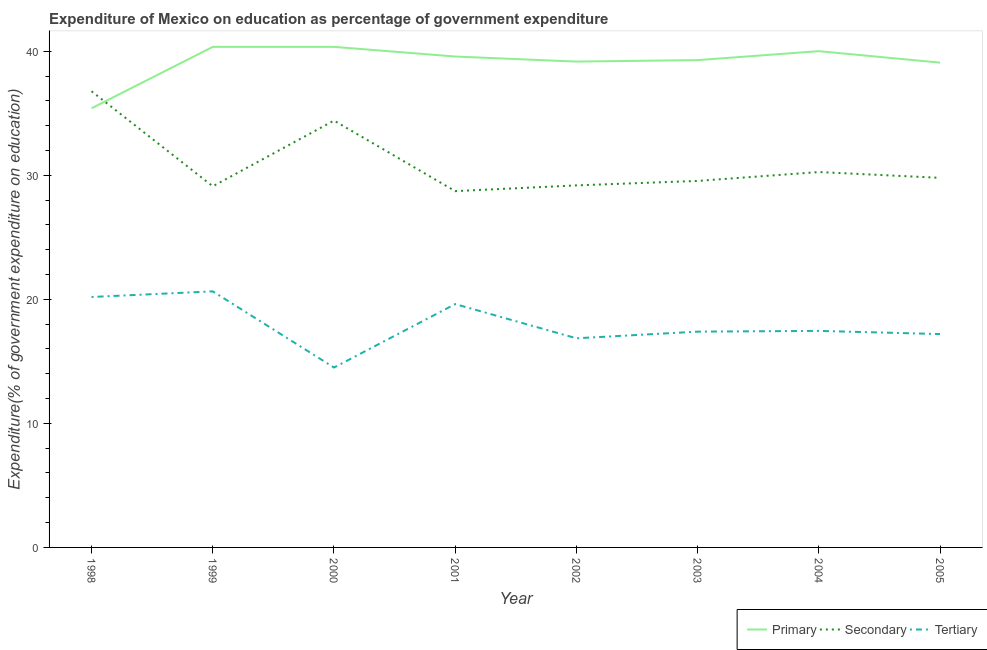Does the line corresponding to expenditure on tertiary education intersect with the line corresponding to expenditure on primary education?
Your answer should be very brief. No. What is the expenditure on secondary education in 2003?
Give a very brief answer. 29.54. Across all years, what is the maximum expenditure on primary education?
Keep it short and to the point. 40.35. Across all years, what is the minimum expenditure on primary education?
Your answer should be compact. 35.4. In which year was the expenditure on tertiary education minimum?
Give a very brief answer. 2000. What is the total expenditure on secondary education in the graph?
Keep it short and to the point. 247.79. What is the difference between the expenditure on tertiary education in 1998 and that in 2000?
Ensure brevity in your answer.  5.69. What is the difference between the expenditure on tertiary education in 2004 and the expenditure on primary education in 2000?
Give a very brief answer. -22.9. What is the average expenditure on tertiary education per year?
Your answer should be compact. 17.98. In the year 1998, what is the difference between the expenditure on tertiary education and expenditure on secondary education?
Make the answer very short. -16.58. What is the ratio of the expenditure on secondary education in 1999 to that in 2002?
Make the answer very short. 1. What is the difference between the highest and the second highest expenditure on secondary education?
Your response must be concise. 2.37. What is the difference between the highest and the lowest expenditure on primary education?
Make the answer very short. 4.95. In how many years, is the expenditure on secondary education greater than the average expenditure on secondary education taken over all years?
Offer a terse response. 2. Is the sum of the expenditure on tertiary education in 1999 and 2005 greater than the maximum expenditure on secondary education across all years?
Provide a short and direct response. Yes. Is it the case that in every year, the sum of the expenditure on primary education and expenditure on secondary education is greater than the expenditure on tertiary education?
Give a very brief answer. Yes. Is the expenditure on secondary education strictly greater than the expenditure on primary education over the years?
Offer a terse response. No. What is the difference between two consecutive major ticks on the Y-axis?
Give a very brief answer. 10. Does the graph contain any zero values?
Your answer should be very brief. No. Does the graph contain grids?
Keep it short and to the point. No. How many legend labels are there?
Your answer should be very brief. 3. What is the title of the graph?
Give a very brief answer. Expenditure of Mexico on education as percentage of government expenditure. Does "Agriculture" appear as one of the legend labels in the graph?
Give a very brief answer. No. What is the label or title of the Y-axis?
Offer a terse response. Expenditure(% of government expenditure on education). What is the Expenditure(% of government expenditure on education) of Primary in 1998?
Your answer should be compact. 35.4. What is the Expenditure(% of government expenditure on education) in Secondary in 1998?
Your answer should be very brief. 36.77. What is the Expenditure(% of government expenditure on education) in Tertiary in 1998?
Offer a very short reply. 20.19. What is the Expenditure(% of government expenditure on education) in Primary in 1999?
Offer a very short reply. 40.35. What is the Expenditure(% of government expenditure on education) of Secondary in 1999?
Keep it short and to the point. 29.11. What is the Expenditure(% of government expenditure on education) in Tertiary in 1999?
Offer a terse response. 20.64. What is the Expenditure(% of government expenditure on education) in Primary in 2000?
Your answer should be compact. 40.35. What is the Expenditure(% of government expenditure on education) of Secondary in 2000?
Provide a short and direct response. 34.41. What is the Expenditure(% of government expenditure on education) in Tertiary in 2000?
Your answer should be compact. 14.5. What is the Expenditure(% of government expenditure on education) of Primary in 2001?
Make the answer very short. 39.57. What is the Expenditure(% of government expenditure on education) of Secondary in 2001?
Provide a short and direct response. 28.72. What is the Expenditure(% of government expenditure on education) in Tertiary in 2001?
Provide a succinct answer. 19.62. What is the Expenditure(% of government expenditure on education) of Primary in 2002?
Give a very brief answer. 39.16. What is the Expenditure(% of government expenditure on education) in Secondary in 2002?
Keep it short and to the point. 29.18. What is the Expenditure(% of government expenditure on education) in Tertiary in 2002?
Give a very brief answer. 16.86. What is the Expenditure(% of government expenditure on education) in Primary in 2003?
Make the answer very short. 39.28. What is the Expenditure(% of government expenditure on education) of Secondary in 2003?
Ensure brevity in your answer.  29.54. What is the Expenditure(% of government expenditure on education) in Tertiary in 2003?
Your answer should be very brief. 17.39. What is the Expenditure(% of government expenditure on education) in Primary in 2004?
Make the answer very short. 40. What is the Expenditure(% of government expenditure on education) of Secondary in 2004?
Your response must be concise. 30.26. What is the Expenditure(% of government expenditure on education) of Tertiary in 2004?
Provide a succinct answer. 17.45. What is the Expenditure(% of government expenditure on education) of Primary in 2005?
Your answer should be compact. 39.08. What is the Expenditure(% of government expenditure on education) of Secondary in 2005?
Your answer should be very brief. 29.79. What is the Expenditure(% of government expenditure on education) in Tertiary in 2005?
Provide a succinct answer. 17.2. Across all years, what is the maximum Expenditure(% of government expenditure on education) of Primary?
Your response must be concise. 40.35. Across all years, what is the maximum Expenditure(% of government expenditure on education) in Secondary?
Provide a short and direct response. 36.77. Across all years, what is the maximum Expenditure(% of government expenditure on education) in Tertiary?
Offer a terse response. 20.64. Across all years, what is the minimum Expenditure(% of government expenditure on education) in Primary?
Keep it short and to the point. 35.4. Across all years, what is the minimum Expenditure(% of government expenditure on education) in Secondary?
Offer a terse response. 28.72. Across all years, what is the minimum Expenditure(% of government expenditure on education) in Tertiary?
Give a very brief answer. 14.5. What is the total Expenditure(% of government expenditure on education) of Primary in the graph?
Provide a succinct answer. 313.2. What is the total Expenditure(% of government expenditure on education) of Secondary in the graph?
Make the answer very short. 247.79. What is the total Expenditure(% of government expenditure on education) of Tertiary in the graph?
Provide a succinct answer. 143.85. What is the difference between the Expenditure(% of government expenditure on education) in Primary in 1998 and that in 1999?
Keep it short and to the point. -4.95. What is the difference between the Expenditure(% of government expenditure on education) of Secondary in 1998 and that in 1999?
Give a very brief answer. 7.66. What is the difference between the Expenditure(% of government expenditure on education) in Tertiary in 1998 and that in 1999?
Your answer should be very brief. -0.45. What is the difference between the Expenditure(% of government expenditure on education) of Primary in 1998 and that in 2000?
Ensure brevity in your answer.  -4.95. What is the difference between the Expenditure(% of government expenditure on education) of Secondary in 1998 and that in 2000?
Your response must be concise. 2.37. What is the difference between the Expenditure(% of government expenditure on education) of Tertiary in 1998 and that in 2000?
Give a very brief answer. 5.69. What is the difference between the Expenditure(% of government expenditure on education) in Primary in 1998 and that in 2001?
Your response must be concise. -4.17. What is the difference between the Expenditure(% of government expenditure on education) of Secondary in 1998 and that in 2001?
Ensure brevity in your answer.  8.05. What is the difference between the Expenditure(% of government expenditure on education) of Tertiary in 1998 and that in 2001?
Provide a succinct answer. 0.57. What is the difference between the Expenditure(% of government expenditure on education) of Primary in 1998 and that in 2002?
Your response must be concise. -3.77. What is the difference between the Expenditure(% of government expenditure on education) of Secondary in 1998 and that in 2002?
Make the answer very short. 7.59. What is the difference between the Expenditure(% of government expenditure on education) in Tertiary in 1998 and that in 2002?
Give a very brief answer. 3.33. What is the difference between the Expenditure(% of government expenditure on education) of Primary in 1998 and that in 2003?
Your response must be concise. -3.89. What is the difference between the Expenditure(% of government expenditure on education) in Secondary in 1998 and that in 2003?
Ensure brevity in your answer.  7.23. What is the difference between the Expenditure(% of government expenditure on education) in Tertiary in 1998 and that in 2003?
Provide a succinct answer. 2.79. What is the difference between the Expenditure(% of government expenditure on education) in Primary in 1998 and that in 2004?
Make the answer very short. -4.61. What is the difference between the Expenditure(% of government expenditure on education) of Secondary in 1998 and that in 2004?
Make the answer very short. 6.51. What is the difference between the Expenditure(% of government expenditure on education) of Tertiary in 1998 and that in 2004?
Make the answer very short. 2.73. What is the difference between the Expenditure(% of government expenditure on education) of Primary in 1998 and that in 2005?
Offer a terse response. -3.68. What is the difference between the Expenditure(% of government expenditure on education) of Secondary in 1998 and that in 2005?
Keep it short and to the point. 6.98. What is the difference between the Expenditure(% of government expenditure on education) of Tertiary in 1998 and that in 2005?
Offer a very short reply. 2.99. What is the difference between the Expenditure(% of government expenditure on education) of Secondary in 1999 and that in 2000?
Provide a short and direct response. -5.3. What is the difference between the Expenditure(% of government expenditure on education) in Tertiary in 1999 and that in 2000?
Provide a short and direct response. 6.14. What is the difference between the Expenditure(% of government expenditure on education) of Primary in 1999 and that in 2001?
Your response must be concise. 0.78. What is the difference between the Expenditure(% of government expenditure on education) of Secondary in 1999 and that in 2001?
Provide a succinct answer. 0.39. What is the difference between the Expenditure(% of government expenditure on education) in Tertiary in 1999 and that in 2001?
Offer a terse response. 1.03. What is the difference between the Expenditure(% of government expenditure on education) in Primary in 1999 and that in 2002?
Provide a short and direct response. 1.19. What is the difference between the Expenditure(% of government expenditure on education) in Secondary in 1999 and that in 2002?
Offer a terse response. -0.07. What is the difference between the Expenditure(% of government expenditure on education) of Tertiary in 1999 and that in 2002?
Your answer should be compact. 3.78. What is the difference between the Expenditure(% of government expenditure on education) in Primary in 1999 and that in 2003?
Your response must be concise. 1.07. What is the difference between the Expenditure(% of government expenditure on education) in Secondary in 1999 and that in 2003?
Your answer should be compact. -0.43. What is the difference between the Expenditure(% of government expenditure on education) of Tertiary in 1999 and that in 2003?
Provide a succinct answer. 3.25. What is the difference between the Expenditure(% of government expenditure on education) of Primary in 1999 and that in 2004?
Provide a short and direct response. 0.35. What is the difference between the Expenditure(% of government expenditure on education) in Secondary in 1999 and that in 2004?
Offer a very short reply. -1.15. What is the difference between the Expenditure(% of government expenditure on education) of Tertiary in 1999 and that in 2004?
Keep it short and to the point. 3.19. What is the difference between the Expenditure(% of government expenditure on education) in Primary in 1999 and that in 2005?
Offer a terse response. 1.27. What is the difference between the Expenditure(% of government expenditure on education) in Secondary in 1999 and that in 2005?
Provide a short and direct response. -0.68. What is the difference between the Expenditure(% of government expenditure on education) in Tertiary in 1999 and that in 2005?
Provide a succinct answer. 3.44. What is the difference between the Expenditure(% of government expenditure on education) of Primary in 2000 and that in 2001?
Your answer should be compact. 0.78. What is the difference between the Expenditure(% of government expenditure on education) in Secondary in 2000 and that in 2001?
Offer a terse response. 5.69. What is the difference between the Expenditure(% of government expenditure on education) of Tertiary in 2000 and that in 2001?
Your response must be concise. -5.11. What is the difference between the Expenditure(% of government expenditure on education) of Primary in 2000 and that in 2002?
Give a very brief answer. 1.19. What is the difference between the Expenditure(% of government expenditure on education) of Secondary in 2000 and that in 2002?
Ensure brevity in your answer.  5.22. What is the difference between the Expenditure(% of government expenditure on education) of Tertiary in 2000 and that in 2002?
Offer a very short reply. -2.36. What is the difference between the Expenditure(% of government expenditure on education) in Primary in 2000 and that in 2003?
Your response must be concise. 1.07. What is the difference between the Expenditure(% of government expenditure on education) of Secondary in 2000 and that in 2003?
Give a very brief answer. 4.86. What is the difference between the Expenditure(% of government expenditure on education) in Tertiary in 2000 and that in 2003?
Keep it short and to the point. -2.89. What is the difference between the Expenditure(% of government expenditure on education) of Primary in 2000 and that in 2004?
Make the answer very short. 0.35. What is the difference between the Expenditure(% of government expenditure on education) of Secondary in 2000 and that in 2004?
Your response must be concise. 4.15. What is the difference between the Expenditure(% of government expenditure on education) in Tertiary in 2000 and that in 2004?
Ensure brevity in your answer.  -2.95. What is the difference between the Expenditure(% of government expenditure on education) in Primary in 2000 and that in 2005?
Keep it short and to the point. 1.27. What is the difference between the Expenditure(% of government expenditure on education) of Secondary in 2000 and that in 2005?
Offer a very short reply. 4.62. What is the difference between the Expenditure(% of government expenditure on education) of Tertiary in 2000 and that in 2005?
Provide a succinct answer. -2.7. What is the difference between the Expenditure(% of government expenditure on education) of Primary in 2001 and that in 2002?
Ensure brevity in your answer.  0.41. What is the difference between the Expenditure(% of government expenditure on education) in Secondary in 2001 and that in 2002?
Your answer should be compact. -0.46. What is the difference between the Expenditure(% of government expenditure on education) of Tertiary in 2001 and that in 2002?
Ensure brevity in your answer.  2.76. What is the difference between the Expenditure(% of government expenditure on education) of Primary in 2001 and that in 2003?
Offer a very short reply. 0.29. What is the difference between the Expenditure(% of government expenditure on education) of Secondary in 2001 and that in 2003?
Make the answer very short. -0.82. What is the difference between the Expenditure(% of government expenditure on education) in Tertiary in 2001 and that in 2003?
Your answer should be compact. 2.22. What is the difference between the Expenditure(% of government expenditure on education) in Primary in 2001 and that in 2004?
Your answer should be compact. -0.43. What is the difference between the Expenditure(% of government expenditure on education) of Secondary in 2001 and that in 2004?
Your answer should be very brief. -1.54. What is the difference between the Expenditure(% of government expenditure on education) of Tertiary in 2001 and that in 2004?
Provide a short and direct response. 2.16. What is the difference between the Expenditure(% of government expenditure on education) in Primary in 2001 and that in 2005?
Your answer should be very brief. 0.49. What is the difference between the Expenditure(% of government expenditure on education) in Secondary in 2001 and that in 2005?
Ensure brevity in your answer.  -1.07. What is the difference between the Expenditure(% of government expenditure on education) of Tertiary in 2001 and that in 2005?
Your answer should be very brief. 2.42. What is the difference between the Expenditure(% of government expenditure on education) of Primary in 2002 and that in 2003?
Your response must be concise. -0.12. What is the difference between the Expenditure(% of government expenditure on education) in Secondary in 2002 and that in 2003?
Provide a short and direct response. -0.36. What is the difference between the Expenditure(% of government expenditure on education) of Tertiary in 2002 and that in 2003?
Offer a terse response. -0.54. What is the difference between the Expenditure(% of government expenditure on education) in Primary in 2002 and that in 2004?
Provide a succinct answer. -0.84. What is the difference between the Expenditure(% of government expenditure on education) in Secondary in 2002 and that in 2004?
Your response must be concise. -1.08. What is the difference between the Expenditure(% of government expenditure on education) of Tertiary in 2002 and that in 2004?
Your answer should be very brief. -0.6. What is the difference between the Expenditure(% of government expenditure on education) of Primary in 2002 and that in 2005?
Your answer should be very brief. 0.09. What is the difference between the Expenditure(% of government expenditure on education) of Secondary in 2002 and that in 2005?
Provide a short and direct response. -0.61. What is the difference between the Expenditure(% of government expenditure on education) in Tertiary in 2002 and that in 2005?
Offer a terse response. -0.34. What is the difference between the Expenditure(% of government expenditure on education) of Primary in 2003 and that in 2004?
Your answer should be compact. -0.72. What is the difference between the Expenditure(% of government expenditure on education) in Secondary in 2003 and that in 2004?
Make the answer very short. -0.72. What is the difference between the Expenditure(% of government expenditure on education) in Tertiary in 2003 and that in 2004?
Your response must be concise. -0.06. What is the difference between the Expenditure(% of government expenditure on education) of Primary in 2003 and that in 2005?
Make the answer very short. 0.2. What is the difference between the Expenditure(% of government expenditure on education) in Secondary in 2003 and that in 2005?
Offer a terse response. -0.25. What is the difference between the Expenditure(% of government expenditure on education) in Tertiary in 2003 and that in 2005?
Your response must be concise. 0.2. What is the difference between the Expenditure(% of government expenditure on education) of Primary in 2004 and that in 2005?
Keep it short and to the point. 0.92. What is the difference between the Expenditure(% of government expenditure on education) of Secondary in 2004 and that in 2005?
Ensure brevity in your answer.  0.47. What is the difference between the Expenditure(% of government expenditure on education) in Tertiary in 2004 and that in 2005?
Provide a succinct answer. 0.26. What is the difference between the Expenditure(% of government expenditure on education) in Primary in 1998 and the Expenditure(% of government expenditure on education) in Secondary in 1999?
Your answer should be very brief. 6.29. What is the difference between the Expenditure(% of government expenditure on education) of Primary in 1998 and the Expenditure(% of government expenditure on education) of Tertiary in 1999?
Give a very brief answer. 14.76. What is the difference between the Expenditure(% of government expenditure on education) of Secondary in 1998 and the Expenditure(% of government expenditure on education) of Tertiary in 1999?
Your answer should be very brief. 16.13. What is the difference between the Expenditure(% of government expenditure on education) of Primary in 1998 and the Expenditure(% of government expenditure on education) of Tertiary in 2000?
Provide a succinct answer. 20.9. What is the difference between the Expenditure(% of government expenditure on education) of Secondary in 1998 and the Expenditure(% of government expenditure on education) of Tertiary in 2000?
Give a very brief answer. 22.27. What is the difference between the Expenditure(% of government expenditure on education) of Primary in 1998 and the Expenditure(% of government expenditure on education) of Secondary in 2001?
Ensure brevity in your answer.  6.68. What is the difference between the Expenditure(% of government expenditure on education) of Primary in 1998 and the Expenditure(% of government expenditure on education) of Tertiary in 2001?
Your answer should be compact. 15.78. What is the difference between the Expenditure(% of government expenditure on education) of Secondary in 1998 and the Expenditure(% of government expenditure on education) of Tertiary in 2001?
Make the answer very short. 17.16. What is the difference between the Expenditure(% of government expenditure on education) of Primary in 1998 and the Expenditure(% of government expenditure on education) of Secondary in 2002?
Offer a terse response. 6.21. What is the difference between the Expenditure(% of government expenditure on education) in Primary in 1998 and the Expenditure(% of government expenditure on education) in Tertiary in 2002?
Make the answer very short. 18.54. What is the difference between the Expenditure(% of government expenditure on education) of Secondary in 1998 and the Expenditure(% of government expenditure on education) of Tertiary in 2002?
Ensure brevity in your answer.  19.91. What is the difference between the Expenditure(% of government expenditure on education) of Primary in 1998 and the Expenditure(% of government expenditure on education) of Secondary in 2003?
Your response must be concise. 5.85. What is the difference between the Expenditure(% of government expenditure on education) of Primary in 1998 and the Expenditure(% of government expenditure on education) of Tertiary in 2003?
Give a very brief answer. 18. What is the difference between the Expenditure(% of government expenditure on education) in Secondary in 1998 and the Expenditure(% of government expenditure on education) in Tertiary in 2003?
Give a very brief answer. 19.38. What is the difference between the Expenditure(% of government expenditure on education) in Primary in 1998 and the Expenditure(% of government expenditure on education) in Secondary in 2004?
Provide a short and direct response. 5.14. What is the difference between the Expenditure(% of government expenditure on education) of Primary in 1998 and the Expenditure(% of government expenditure on education) of Tertiary in 2004?
Your answer should be very brief. 17.94. What is the difference between the Expenditure(% of government expenditure on education) in Secondary in 1998 and the Expenditure(% of government expenditure on education) in Tertiary in 2004?
Your response must be concise. 19.32. What is the difference between the Expenditure(% of government expenditure on education) in Primary in 1998 and the Expenditure(% of government expenditure on education) in Secondary in 2005?
Your response must be concise. 5.61. What is the difference between the Expenditure(% of government expenditure on education) of Primary in 1998 and the Expenditure(% of government expenditure on education) of Tertiary in 2005?
Your response must be concise. 18.2. What is the difference between the Expenditure(% of government expenditure on education) in Secondary in 1998 and the Expenditure(% of government expenditure on education) in Tertiary in 2005?
Offer a very short reply. 19.57. What is the difference between the Expenditure(% of government expenditure on education) of Primary in 1999 and the Expenditure(% of government expenditure on education) of Secondary in 2000?
Keep it short and to the point. 5.94. What is the difference between the Expenditure(% of government expenditure on education) of Primary in 1999 and the Expenditure(% of government expenditure on education) of Tertiary in 2000?
Ensure brevity in your answer.  25.85. What is the difference between the Expenditure(% of government expenditure on education) of Secondary in 1999 and the Expenditure(% of government expenditure on education) of Tertiary in 2000?
Ensure brevity in your answer.  14.61. What is the difference between the Expenditure(% of government expenditure on education) in Primary in 1999 and the Expenditure(% of government expenditure on education) in Secondary in 2001?
Provide a succinct answer. 11.63. What is the difference between the Expenditure(% of government expenditure on education) in Primary in 1999 and the Expenditure(% of government expenditure on education) in Tertiary in 2001?
Make the answer very short. 20.74. What is the difference between the Expenditure(% of government expenditure on education) of Secondary in 1999 and the Expenditure(% of government expenditure on education) of Tertiary in 2001?
Make the answer very short. 9.5. What is the difference between the Expenditure(% of government expenditure on education) of Primary in 1999 and the Expenditure(% of government expenditure on education) of Secondary in 2002?
Keep it short and to the point. 11.17. What is the difference between the Expenditure(% of government expenditure on education) in Primary in 1999 and the Expenditure(% of government expenditure on education) in Tertiary in 2002?
Offer a very short reply. 23.49. What is the difference between the Expenditure(% of government expenditure on education) in Secondary in 1999 and the Expenditure(% of government expenditure on education) in Tertiary in 2002?
Ensure brevity in your answer.  12.25. What is the difference between the Expenditure(% of government expenditure on education) of Primary in 1999 and the Expenditure(% of government expenditure on education) of Secondary in 2003?
Offer a terse response. 10.81. What is the difference between the Expenditure(% of government expenditure on education) in Primary in 1999 and the Expenditure(% of government expenditure on education) in Tertiary in 2003?
Make the answer very short. 22.96. What is the difference between the Expenditure(% of government expenditure on education) of Secondary in 1999 and the Expenditure(% of government expenditure on education) of Tertiary in 2003?
Keep it short and to the point. 11.72. What is the difference between the Expenditure(% of government expenditure on education) of Primary in 1999 and the Expenditure(% of government expenditure on education) of Secondary in 2004?
Your answer should be compact. 10.09. What is the difference between the Expenditure(% of government expenditure on education) in Primary in 1999 and the Expenditure(% of government expenditure on education) in Tertiary in 2004?
Keep it short and to the point. 22.9. What is the difference between the Expenditure(% of government expenditure on education) in Secondary in 1999 and the Expenditure(% of government expenditure on education) in Tertiary in 2004?
Provide a short and direct response. 11.66. What is the difference between the Expenditure(% of government expenditure on education) in Primary in 1999 and the Expenditure(% of government expenditure on education) in Secondary in 2005?
Provide a short and direct response. 10.56. What is the difference between the Expenditure(% of government expenditure on education) in Primary in 1999 and the Expenditure(% of government expenditure on education) in Tertiary in 2005?
Make the answer very short. 23.15. What is the difference between the Expenditure(% of government expenditure on education) in Secondary in 1999 and the Expenditure(% of government expenditure on education) in Tertiary in 2005?
Make the answer very short. 11.91. What is the difference between the Expenditure(% of government expenditure on education) of Primary in 2000 and the Expenditure(% of government expenditure on education) of Secondary in 2001?
Your answer should be very brief. 11.63. What is the difference between the Expenditure(% of government expenditure on education) of Primary in 2000 and the Expenditure(% of government expenditure on education) of Tertiary in 2001?
Make the answer very short. 20.74. What is the difference between the Expenditure(% of government expenditure on education) of Secondary in 2000 and the Expenditure(% of government expenditure on education) of Tertiary in 2001?
Make the answer very short. 14.79. What is the difference between the Expenditure(% of government expenditure on education) in Primary in 2000 and the Expenditure(% of government expenditure on education) in Secondary in 2002?
Your answer should be compact. 11.17. What is the difference between the Expenditure(% of government expenditure on education) in Primary in 2000 and the Expenditure(% of government expenditure on education) in Tertiary in 2002?
Keep it short and to the point. 23.49. What is the difference between the Expenditure(% of government expenditure on education) in Secondary in 2000 and the Expenditure(% of government expenditure on education) in Tertiary in 2002?
Your answer should be compact. 17.55. What is the difference between the Expenditure(% of government expenditure on education) in Primary in 2000 and the Expenditure(% of government expenditure on education) in Secondary in 2003?
Your answer should be compact. 10.81. What is the difference between the Expenditure(% of government expenditure on education) in Primary in 2000 and the Expenditure(% of government expenditure on education) in Tertiary in 2003?
Your response must be concise. 22.96. What is the difference between the Expenditure(% of government expenditure on education) of Secondary in 2000 and the Expenditure(% of government expenditure on education) of Tertiary in 2003?
Provide a short and direct response. 17.01. What is the difference between the Expenditure(% of government expenditure on education) in Primary in 2000 and the Expenditure(% of government expenditure on education) in Secondary in 2004?
Offer a very short reply. 10.09. What is the difference between the Expenditure(% of government expenditure on education) in Primary in 2000 and the Expenditure(% of government expenditure on education) in Tertiary in 2004?
Provide a succinct answer. 22.9. What is the difference between the Expenditure(% of government expenditure on education) in Secondary in 2000 and the Expenditure(% of government expenditure on education) in Tertiary in 2004?
Ensure brevity in your answer.  16.95. What is the difference between the Expenditure(% of government expenditure on education) in Primary in 2000 and the Expenditure(% of government expenditure on education) in Secondary in 2005?
Make the answer very short. 10.56. What is the difference between the Expenditure(% of government expenditure on education) in Primary in 2000 and the Expenditure(% of government expenditure on education) in Tertiary in 2005?
Your response must be concise. 23.15. What is the difference between the Expenditure(% of government expenditure on education) in Secondary in 2000 and the Expenditure(% of government expenditure on education) in Tertiary in 2005?
Offer a very short reply. 17.21. What is the difference between the Expenditure(% of government expenditure on education) in Primary in 2001 and the Expenditure(% of government expenditure on education) in Secondary in 2002?
Your answer should be compact. 10.39. What is the difference between the Expenditure(% of government expenditure on education) of Primary in 2001 and the Expenditure(% of government expenditure on education) of Tertiary in 2002?
Offer a very short reply. 22.71. What is the difference between the Expenditure(% of government expenditure on education) in Secondary in 2001 and the Expenditure(% of government expenditure on education) in Tertiary in 2002?
Provide a short and direct response. 11.86. What is the difference between the Expenditure(% of government expenditure on education) in Primary in 2001 and the Expenditure(% of government expenditure on education) in Secondary in 2003?
Give a very brief answer. 10.03. What is the difference between the Expenditure(% of government expenditure on education) of Primary in 2001 and the Expenditure(% of government expenditure on education) of Tertiary in 2003?
Offer a terse response. 22.18. What is the difference between the Expenditure(% of government expenditure on education) in Secondary in 2001 and the Expenditure(% of government expenditure on education) in Tertiary in 2003?
Ensure brevity in your answer.  11.33. What is the difference between the Expenditure(% of government expenditure on education) of Primary in 2001 and the Expenditure(% of government expenditure on education) of Secondary in 2004?
Your answer should be compact. 9.31. What is the difference between the Expenditure(% of government expenditure on education) of Primary in 2001 and the Expenditure(% of government expenditure on education) of Tertiary in 2004?
Your answer should be compact. 22.12. What is the difference between the Expenditure(% of government expenditure on education) of Secondary in 2001 and the Expenditure(% of government expenditure on education) of Tertiary in 2004?
Provide a short and direct response. 11.27. What is the difference between the Expenditure(% of government expenditure on education) in Primary in 2001 and the Expenditure(% of government expenditure on education) in Secondary in 2005?
Offer a very short reply. 9.78. What is the difference between the Expenditure(% of government expenditure on education) of Primary in 2001 and the Expenditure(% of government expenditure on education) of Tertiary in 2005?
Provide a succinct answer. 22.37. What is the difference between the Expenditure(% of government expenditure on education) in Secondary in 2001 and the Expenditure(% of government expenditure on education) in Tertiary in 2005?
Give a very brief answer. 11.52. What is the difference between the Expenditure(% of government expenditure on education) in Primary in 2002 and the Expenditure(% of government expenditure on education) in Secondary in 2003?
Offer a very short reply. 9.62. What is the difference between the Expenditure(% of government expenditure on education) of Primary in 2002 and the Expenditure(% of government expenditure on education) of Tertiary in 2003?
Your response must be concise. 21.77. What is the difference between the Expenditure(% of government expenditure on education) in Secondary in 2002 and the Expenditure(% of government expenditure on education) in Tertiary in 2003?
Ensure brevity in your answer.  11.79. What is the difference between the Expenditure(% of government expenditure on education) in Primary in 2002 and the Expenditure(% of government expenditure on education) in Secondary in 2004?
Keep it short and to the point. 8.9. What is the difference between the Expenditure(% of government expenditure on education) of Primary in 2002 and the Expenditure(% of government expenditure on education) of Tertiary in 2004?
Your response must be concise. 21.71. What is the difference between the Expenditure(% of government expenditure on education) of Secondary in 2002 and the Expenditure(% of government expenditure on education) of Tertiary in 2004?
Your answer should be compact. 11.73. What is the difference between the Expenditure(% of government expenditure on education) in Primary in 2002 and the Expenditure(% of government expenditure on education) in Secondary in 2005?
Offer a terse response. 9.37. What is the difference between the Expenditure(% of government expenditure on education) of Primary in 2002 and the Expenditure(% of government expenditure on education) of Tertiary in 2005?
Make the answer very short. 21.97. What is the difference between the Expenditure(% of government expenditure on education) of Secondary in 2002 and the Expenditure(% of government expenditure on education) of Tertiary in 2005?
Offer a terse response. 11.99. What is the difference between the Expenditure(% of government expenditure on education) in Primary in 2003 and the Expenditure(% of government expenditure on education) in Secondary in 2004?
Give a very brief answer. 9.02. What is the difference between the Expenditure(% of government expenditure on education) of Primary in 2003 and the Expenditure(% of government expenditure on education) of Tertiary in 2004?
Provide a succinct answer. 21.83. What is the difference between the Expenditure(% of government expenditure on education) in Secondary in 2003 and the Expenditure(% of government expenditure on education) in Tertiary in 2004?
Offer a very short reply. 12.09. What is the difference between the Expenditure(% of government expenditure on education) of Primary in 2003 and the Expenditure(% of government expenditure on education) of Secondary in 2005?
Make the answer very short. 9.49. What is the difference between the Expenditure(% of government expenditure on education) in Primary in 2003 and the Expenditure(% of government expenditure on education) in Tertiary in 2005?
Your response must be concise. 22.08. What is the difference between the Expenditure(% of government expenditure on education) of Secondary in 2003 and the Expenditure(% of government expenditure on education) of Tertiary in 2005?
Your response must be concise. 12.35. What is the difference between the Expenditure(% of government expenditure on education) of Primary in 2004 and the Expenditure(% of government expenditure on education) of Secondary in 2005?
Your response must be concise. 10.21. What is the difference between the Expenditure(% of government expenditure on education) in Primary in 2004 and the Expenditure(% of government expenditure on education) in Tertiary in 2005?
Provide a succinct answer. 22.8. What is the difference between the Expenditure(% of government expenditure on education) in Secondary in 2004 and the Expenditure(% of government expenditure on education) in Tertiary in 2005?
Provide a short and direct response. 13.06. What is the average Expenditure(% of government expenditure on education) of Primary per year?
Offer a terse response. 39.15. What is the average Expenditure(% of government expenditure on education) in Secondary per year?
Your answer should be very brief. 30.97. What is the average Expenditure(% of government expenditure on education) in Tertiary per year?
Your answer should be very brief. 17.98. In the year 1998, what is the difference between the Expenditure(% of government expenditure on education) in Primary and Expenditure(% of government expenditure on education) in Secondary?
Your answer should be very brief. -1.37. In the year 1998, what is the difference between the Expenditure(% of government expenditure on education) in Primary and Expenditure(% of government expenditure on education) in Tertiary?
Provide a succinct answer. 15.21. In the year 1998, what is the difference between the Expenditure(% of government expenditure on education) in Secondary and Expenditure(% of government expenditure on education) in Tertiary?
Provide a short and direct response. 16.58. In the year 1999, what is the difference between the Expenditure(% of government expenditure on education) of Primary and Expenditure(% of government expenditure on education) of Secondary?
Offer a very short reply. 11.24. In the year 1999, what is the difference between the Expenditure(% of government expenditure on education) in Primary and Expenditure(% of government expenditure on education) in Tertiary?
Offer a terse response. 19.71. In the year 1999, what is the difference between the Expenditure(% of government expenditure on education) in Secondary and Expenditure(% of government expenditure on education) in Tertiary?
Offer a very short reply. 8.47. In the year 2000, what is the difference between the Expenditure(% of government expenditure on education) in Primary and Expenditure(% of government expenditure on education) in Secondary?
Your response must be concise. 5.94. In the year 2000, what is the difference between the Expenditure(% of government expenditure on education) in Primary and Expenditure(% of government expenditure on education) in Tertiary?
Your answer should be compact. 25.85. In the year 2000, what is the difference between the Expenditure(% of government expenditure on education) in Secondary and Expenditure(% of government expenditure on education) in Tertiary?
Offer a very short reply. 19.91. In the year 2001, what is the difference between the Expenditure(% of government expenditure on education) in Primary and Expenditure(% of government expenditure on education) in Secondary?
Your response must be concise. 10.85. In the year 2001, what is the difference between the Expenditure(% of government expenditure on education) in Primary and Expenditure(% of government expenditure on education) in Tertiary?
Ensure brevity in your answer.  19.96. In the year 2001, what is the difference between the Expenditure(% of government expenditure on education) in Secondary and Expenditure(% of government expenditure on education) in Tertiary?
Provide a short and direct response. 9.1. In the year 2002, what is the difference between the Expenditure(% of government expenditure on education) in Primary and Expenditure(% of government expenditure on education) in Secondary?
Provide a succinct answer. 9.98. In the year 2002, what is the difference between the Expenditure(% of government expenditure on education) in Primary and Expenditure(% of government expenditure on education) in Tertiary?
Your answer should be very brief. 22.31. In the year 2002, what is the difference between the Expenditure(% of government expenditure on education) of Secondary and Expenditure(% of government expenditure on education) of Tertiary?
Keep it short and to the point. 12.33. In the year 2003, what is the difference between the Expenditure(% of government expenditure on education) of Primary and Expenditure(% of government expenditure on education) of Secondary?
Provide a succinct answer. 9.74. In the year 2003, what is the difference between the Expenditure(% of government expenditure on education) in Primary and Expenditure(% of government expenditure on education) in Tertiary?
Give a very brief answer. 21.89. In the year 2003, what is the difference between the Expenditure(% of government expenditure on education) of Secondary and Expenditure(% of government expenditure on education) of Tertiary?
Offer a very short reply. 12.15. In the year 2004, what is the difference between the Expenditure(% of government expenditure on education) in Primary and Expenditure(% of government expenditure on education) in Secondary?
Your answer should be compact. 9.74. In the year 2004, what is the difference between the Expenditure(% of government expenditure on education) of Primary and Expenditure(% of government expenditure on education) of Tertiary?
Offer a terse response. 22.55. In the year 2004, what is the difference between the Expenditure(% of government expenditure on education) in Secondary and Expenditure(% of government expenditure on education) in Tertiary?
Offer a very short reply. 12.81. In the year 2005, what is the difference between the Expenditure(% of government expenditure on education) of Primary and Expenditure(% of government expenditure on education) of Secondary?
Ensure brevity in your answer.  9.29. In the year 2005, what is the difference between the Expenditure(% of government expenditure on education) in Primary and Expenditure(% of government expenditure on education) in Tertiary?
Ensure brevity in your answer.  21.88. In the year 2005, what is the difference between the Expenditure(% of government expenditure on education) of Secondary and Expenditure(% of government expenditure on education) of Tertiary?
Make the answer very short. 12.59. What is the ratio of the Expenditure(% of government expenditure on education) in Primary in 1998 to that in 1999?
Make the answer very short. 0.88. What is the ratio of the Expenditure(% of government expenditure on education) of Secondary in 1998 to that in 1999?
Your answer should be compact. 1.26. What is the ratio of the Expenditure(% of government expenditure on education) in Tertiary in 1998 to that in 1999?
Provide a short and direct response. 0.98. What is the ratio of the Expenditure(% of government expenditure on education) in Primary in 1998 to that in 2000?
Your response must be concise. 0.88. What is the ratio of the Expenditure(% of government expenditure on education) in Secondary in 1998 to that in 2000?
Make the answer very short. 1.07. What is the ratio of the Expenditure(% of government expenditure on education) in Tertiary in 1998 to that in 2000?
Keep it short and to the point. 1.39. What is the ratio of the Expenditure(% of government expenditure on education) in Primary in 1998 to that in 2001?
Offer a very short reply. 0.89. What is the ratio of the Expenditure(% of government expenditure on education) of Secondary in 1998 to that in 2001?
Make the answer very short. 1.28. What is the ratio of the Expenditure(% of government expenditure on education) of Tertiary in 1998 to that in 2001?
Give a very brief answer. 1.03. What is the ratio of the Expenditure(% of government expenditure on education) in Primary in 1998 to that in 2002?
Your answer should be very brief. 0.9. What is the ratio of the Expenditure(% of government expenditure on education) in Secondary in 1998 to that in 2002?
Keep it short and to the point. 1.26. What is the ratio of the Expenditure(% of government expenditure on education) of Tertiary in 1998 to that in 2002?
Make the answer very short. 1.2. What is the ratio of the Expenditure(% of government expenditure on education) in Primary in 1998 to that in 2003?
Give a very brief answer. 0.9. What is the ratio of the Expenditure(% of government expenditure on education) in Secondary in 1998 to that in 2003?
Give a very brief answer. 1.24. What is the ratio of the Expenditure(% of government expenditure on education) in Tertiary in 1998 to that in 2003?
Offer a very short reply. 1.16. What is the ratio of the Expenditure(% of government expenditure on education) in Primary in 1998 to that in 2004?
Your answer should be very brief. 0.88. What is the ratio of the Expenditure(% of government expenditure on education) of Secondary in 1998 to that in 2004?
Make the answer very short. 1.22. What is the ratio of the Expenditure(% of government expenditure on education) of Tertiary in 1998 to that in 2004?
Offer a terse response. 1.16. What is the ratio of the Expenditure(% of government expenditure on education) of Primary in 1998 to that in 2005?
Provide a succinct answer. 0.91. What is the ratio of the Expenditure(% of government expenditure on education) in Secondary in 1998 to that in 2005?
Provide a short and direct response. 1.23. What is the ratio of the Expenditure(% of government expenditure on education) in Tertiary in 1998 to that in 2005?
Make the answer very short. 1.17. What is the ratio of the Expenditure(% of government expenditure on education) in Primary in 1999 to that in 2000?
Give a very brief answer. 1. What is the ratio of the Expenditure(% of government expenditure on education) of Secondary in 1999 to that in 2000?
Make the answer very short. 0.85. What is the ratio of the Expenditure(% of government expenditure on education) in Tertiary in 1999 to that in 2000?
Provide a succinct answer. 1.42. What is the ratio of the Expenditure(% of government expenditure on education) of Primary in 1999 to that in 2001?
Keep it short and to the point. 1.02. What is the ratio of the Expenditure(% of government expenditure on education) in Secondary in 1999 to that in 2001?
Provide a short and direct response. 1.01. What is the ratio of the Expenditure(% of government expenditure on education) in Tertiary in 1999 to that in 2001?
Make the answer very short. 1.05. What is the ratio of the Expenditure(% of government expenditure on education) in Primary in 1999 to that in 2002?
Provide a succinct answer. 1.03. What is the ratio of the Expenditure(% of government expenditure on education) in Secondary in 1999 to that in 2002?
Your answer should be very brief. 1. What is the ratio of the Expenditure(% of government expenditure on education) of Tertiary in 1999 to that in 2002?
Provide a succinct answer. 1.22. What is the ratio of the Expenditure(% of government expenditure on education) in Primary in 1999 to that in 2003?
Your answer should be compact. 1.03. What is the ratio of the Expenditure(% of government expenditure on education) in Secondary in 1999 to that in 2003?
Your response must be concise. 0.99. What is the ratio of the Expenditure(% of government expenditure on education) in Tertiary in 1999 to that in 2003?
Your response must be concise. 1.19. What is the ratio of the Expenditure(% of government expenditure on education) in Primary in 1999 to that in 2004?
Offer a terse response. 1.01. What is the ratio of the Expenditure(% of government expenditure on education) in Tertiary in 1999 to that in 2004?
Offer a terse response. 1.18. What is the ratio of the Expenditure(% of government expenditure on education) in Primary in 1999 to that in 2005?
Your answer should be compact. 1.03. What is the ratio of the Expenditure(% of government expenditure on education) in Secondary in 1999 to that in 2005?
Provide a short and direct response. 0.98. What is the ratio of the Expenditure(% of government expenditure on education) of Tertiary in 1999 to that in 2005?
Offer a terse response. 1.2. What is the ratio of the Expenditure(% of government expenditure on education) in Primary in 2000 to that in 2001?
Your answer should be compact. 1.02. What is the ratio of the Expenditure(% of government expenditure on education) of Secondary in 2000 to that in 2001?
Ensure brevity in your answer.  1.2. What is the ratio of the Expenditure(% of government expenditure on education) in Tertiary in 2000 to that in 2001?
Offer a very short reply. 0.74. What is the ratio of the Expenditure(% of government expenditure on education) of Primary in 2000 to that in 2002?
Give a very brief answer. 1.03. What is the ratio of the Expenditure(% of government expenditure on education) in Secondary in 2000 to that in 2002?
Offer a terse response. 1.18. What is the ratio of the Expenditure(% of government expenditure on education) of Tertiary in 2000 to that in 2002?
Offer a terse response. 0.86. What is the ratio of the Expenditure(% of government expenditure on education) of Primary in 2000 to that in 2003?
Your answer should be compact. 1.03. What is the ratio of the Expenditure(% of government expenditure on education) in Secondary in 2000 to that in 2003?
Your response must be concise. 1.16. What is the ratio of the Expenditure(% of government expenditure on education) in Tertiary in 2000 to that in 2003?
Ensure brevity in your answer.  0.83. What is the ratio of the Expenditure(% of government expenditure on education) of Primary in 2000 to that in 2004?
Give a very brief answer. 1.01. What is the ratio of the Expenditure(% of government expenditure on education) of Secondary in 2000 to that in 2004?
Offer a very short reply. 1.14. What is the ratio of the Expenditure(% of government expenditure on education) in Tertiary in 2000 to that in 2004?
Your answer should be very brief. 0.83. What is the ratio of the Expenditure(% of government expenditure on education) in Primary in 2000 to that in 2005?
Your answer should be compact. 1.03. What is the ratio of the Expenditure(% of government expenditure on education) in Secondary in 2000 to that in 2005?
Your answer should be very brief. 1.15. What is the ratio of the Expenditure(% of government expenditure on education) of Tertiary in 2000 to that in 2005?
Ensure brevity in your answer.  0.84. What is the ratio of the Expenditure(% of government expenditure on education) in Primary in 2001 to that in 2002?
Ensure brevity in your answer.  1.01. What is the ratio of the Expenditure(% of government expenditure on education) in Secondary in 2001 to that in 2002?
Provide a short and direct response. 0.98. What is the ratio of the Expenditure(% of government expenditure on education) of Tertiary in 2001 to that in 2002?
Your answer should be compact. 1.16. What is the ratio of the Expenditure(% of government expenditure on education) of Primary in 2001 to that in 2003?
Make the answer very short. 1.01. What is the ratio of the Expenditure(% of government expenditure on education) in Secondary in 2001 to that in 2003?
Offer a very short reply. 0.97. What is the ratio of the Expenditure(% of government expenditure on education) in Tertiary in 2001 to that in 2003?
Ensure brevity in your answer.  1.13. What is the ratio of the Expenditure(% of government expenditure on education) in Secondary in 2001 to that in 2004?
Your response must be concise. 0.95. What is the ratio of the Expenditure(% of government expenditure on education) in Tertiary in 2001 to that in 2004?
Keep it short and to the point. 1.12. What is the ratio of the Expenditure(% of government expenditure on education) of Primary in 2001 to that in 2005?
Provide a short and direct response. 1.01. What is the ratio of the Expenditure(% of government expenditure on education) of Secondary in 2001 to that in 2005?
Offer a very short reply. 0.96. What is the ratio of the Expenditure(% of government expenditure on education) of Tertiary in 2001 to that in 2005?
Give a very brief answer. 1.14. What is the ratio of the Expenditure(% of government expenditure on education) in Tertiary in 2002 to that in 2003?
Provide a succinct answer. 0.97. What is the ratio of the Expenditure(% of government expenditure on education) in Primary in 2002 to that in 2004?
Provide a succinct answer. 0.98. What is the ratio of the Expenditure(% of government expenditure on education) in Secondary in 2002 to that in 2004?
Ensure brevity in your answer.  0.96. What is the ratio of the Expenditure(% of government expenditure on education) in Tertiary in 2002 to that in 2004?
Offer a very short reply. 0.97. What is the ratio of the Expenditure(% of government expenditure on education) in Secondary in 2002 to that in 2005?
Give a very brief answer. 0.98. What is the ratio of the Expenditure(% of government expenditure on education) of Tertiary in 2002 to that in 2005?
Ensure brevity in your answer.  0.98. What is the ratio of the Expenditure(% of government expenditure on education) in Secondary in 2003 to that in 2004?
Provide a succinct answer. 0.98. What is the ratio of the Expenditure(% of government expenditure on education) of Tertiary in 2003 to that in 2004?
Make the answer very short. 1. What is the ratio of the Expenditure(% of government expenditure on education) in Primary in 2003 to that in 2005?
Your response must be concise. 1.01. What is the ratio of the Expenditure(% of government expenditure on education) in Tertiary in 2003 to that in 2005?
Your response must be concise. 1.01. What is the ratio of the Expenditure(% of government expenditure on education) in Primary in 2004 to that in 2005?
Provide a succinct answer. 1.02. What is the ratio of the Expenditure(% of government expenditure on education) in Secondary in 2004 to that in 2005?
Make the answer very short. 1.02. What is the ratio of the Expenditure(% of government expenditure on education) of Tertiary in 2004 to that in 2005?
Make the answer very short. 1.01. What is the difference between the highest and the second highest Expenditure(% of government expenditure on education) in Primary?
Offer a terse response. 0. What is the difference between the highest and the second highest Expenditure(% of government expenditure on education) of Secondary?
Your answer should be compact. 2.37. What is the difference between the highest and the second highest Expenditure(% of government expenditure on education) in Tertiary?
Give a very brief answer. 0.45. What is the difference between the highest and the lowest Expenditure(% of government expenditure on education) in Primary?
Offer a very short reply. 4.95. What is the difference between the highest and the lowest Expenditure(% of government expenditure on education) in Secondary?
Offer a terse response. 8.05. What is the difference between the highest and the lowest Expenditure(% of government expenditure on education) in Tertiary?
Keep it short and to the point. 6.14. 